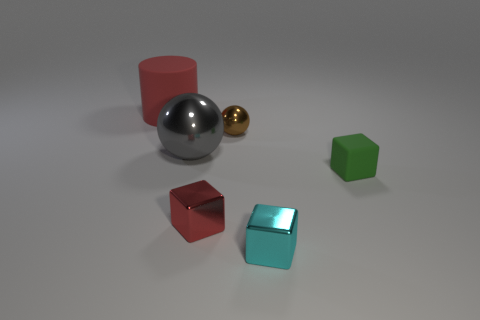There is a small block that is made of the same material as the tiny cyan object; what color is it?
Your answer should be compact. Red. Is the number of big red objects in front of the tiny cyan cube greater than the number of balls that are left of the tiny red cube?
Your answer should be very brief. No. Is there a green cube?
Make the answer very short. Yes. There is another object that is the same color as the large rubber thing; what is its material?
Ensure brevity in your answer.  Metal. What number of things are either big things or tiny brown rubber objects?
Ensure brevity in your answer.  2. Are there any other rubber things of the same color as the large rubber object?
Ensure brevity in your answer.  No. There is a brown metallic ball in front of the large red matte cylinder; what number of tiny red metallic blocks are behind it?
Ensure brevity in your answer.  0. Are there more small red shiny things than large purple matte cylinders?
Give a very brief answer. Yes. Do the cylinder and the green cube have the same material?
Offer a terse response. Yes. Are there an equal number of gray spheres behind the small red metallic block and tiny cyan metal things?
Give a very brief answer. Yes. 